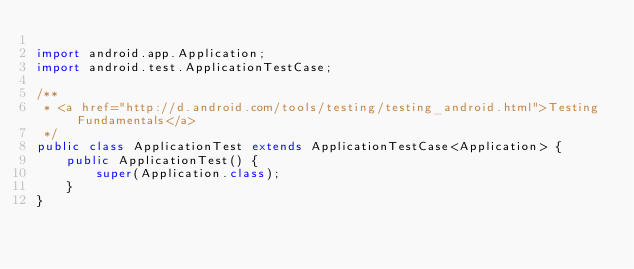<code> <loc_0><loc_0><loc_500><loc_500><_Java_>
import android.app.Application;
import android.test.ApplicationTestCase;

/**
 * <a href="http://d.android.com/tools/testing/testing_android.html">Testing Fundamentals</a>
 */
public class ApplicationTest extends ApplicationTestCase<Application> {
    public ApplicationTest() {
        super(Application.class);
    }
}</code> 